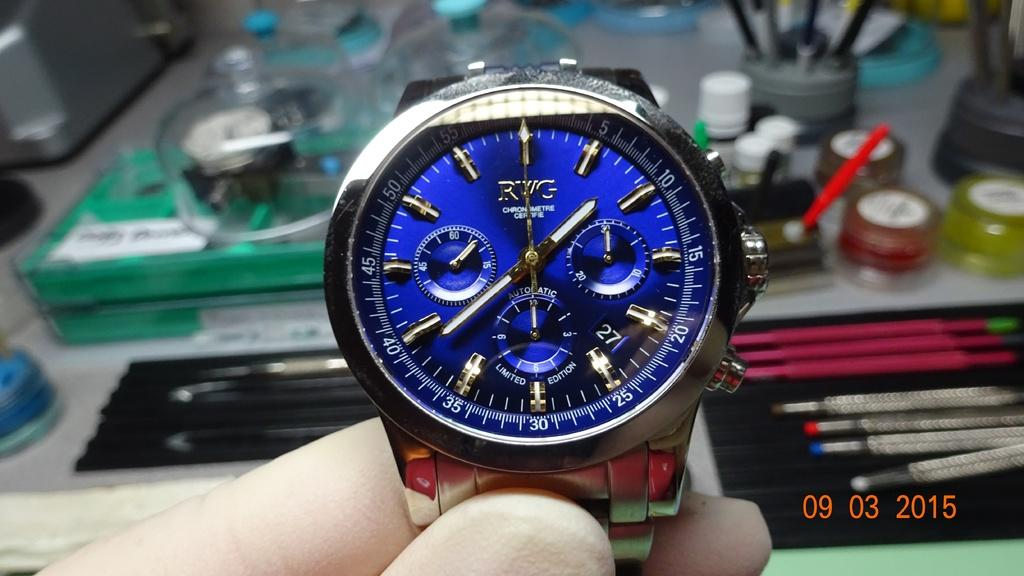<image>
Summarize the visual content of the image. A photo taken in 2015 of an RWG watch with a blue face. 